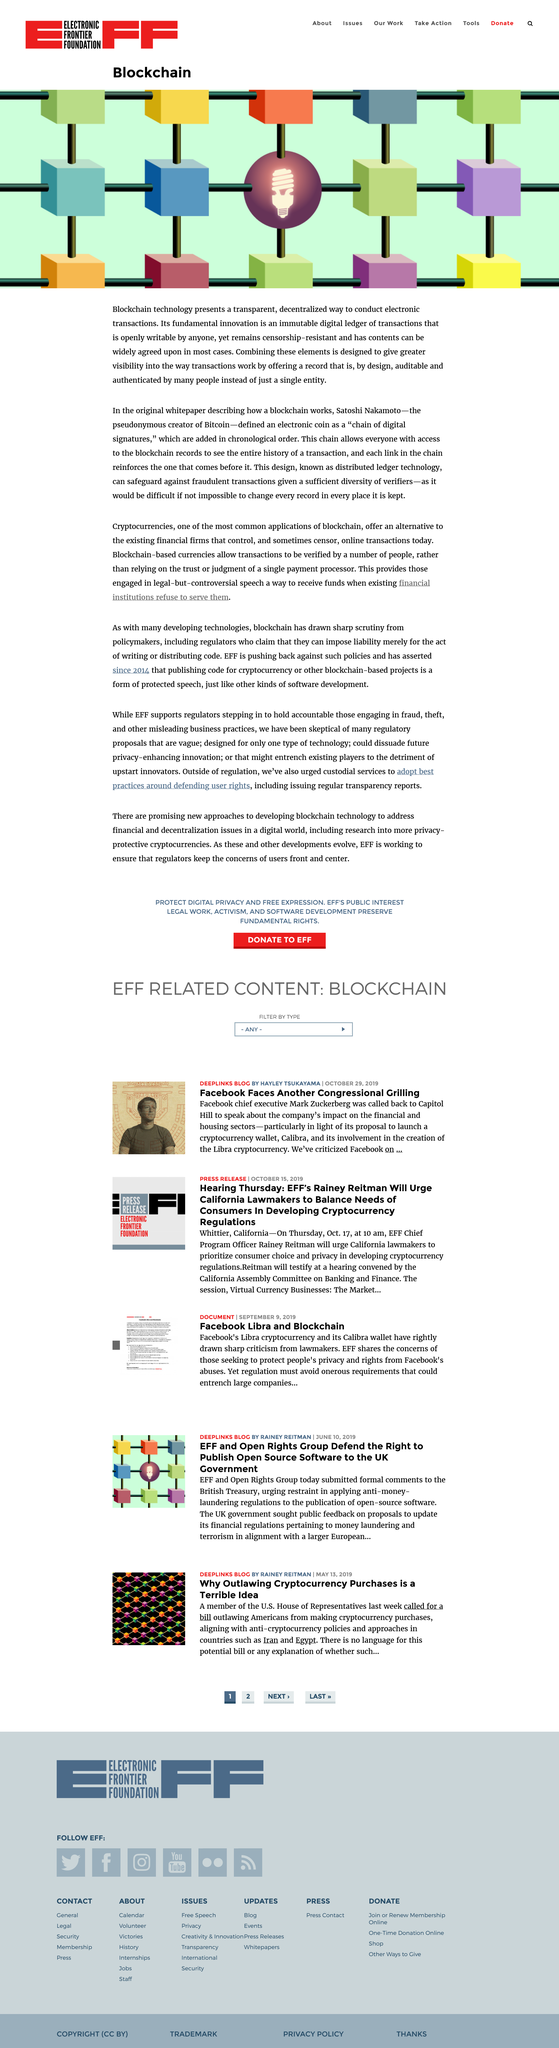Draw attention to some important aspects in this diagram. Satoshi Nakamoto is the pseudonymous creator of Bitcoin, who is widely recognized as the inventor of the cryptocurrency. Blockchain technology represents a transparent and decentralized method for conducting electronic transactions that is free from interference and tampering. Satoshi Nakamoto defined an electronic coin as a "chain of digital signatures" in a declaration. 